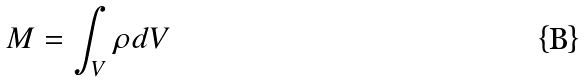<formula> <loc_0><loc_0><loc_500><loc_500>M = \int _ { V } \rho d V</formula> 